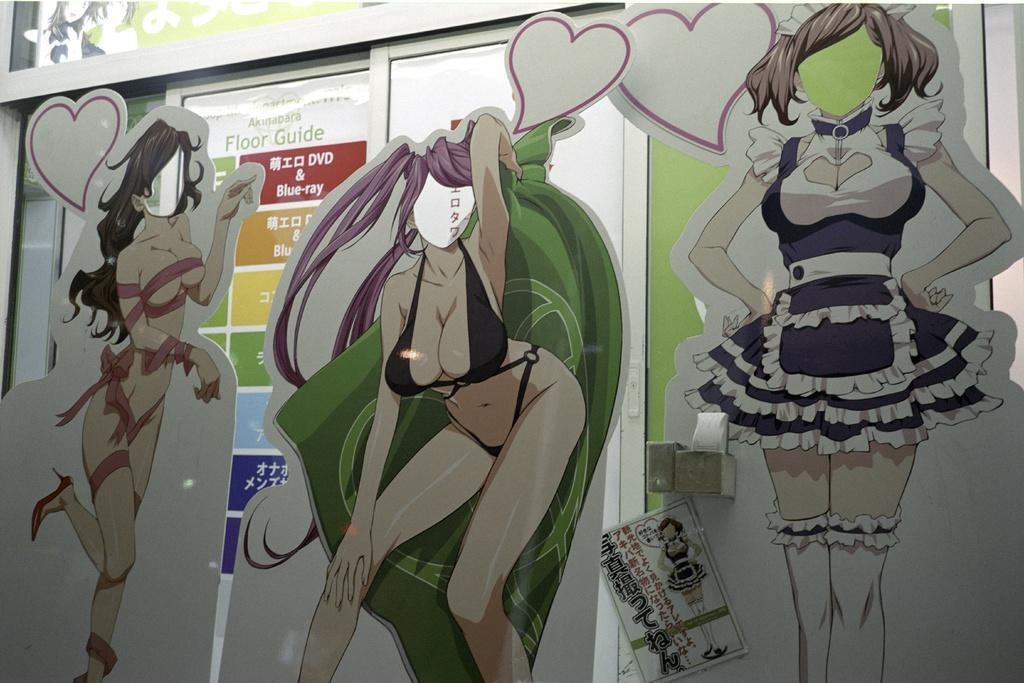How many cardboards are present in the image? There are three cardboards in the image. What design is featured on the cardboards? The cardboards are cut in the design of a girl. What can be seen in the background of the image? There is a sliding door in the background of the image. What type of salt is sprinkled on the cardboards in the image? There is no salt present on the cardboards in the image. What kind of powder can be seen falling from the ceiling in the image? There is no powder falling from the ceiling in the image. 